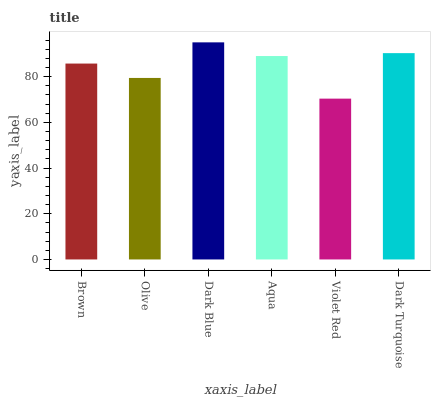Is Violet Red the minimum?
Answer yes or no. Yes. Is Dark Blue the maximum?
Answer yes or no. Yes. Is Olive the minimum?
Answer yes or no. No. Is Olive the maximum?
Answer yes or no. No. Is Brown greater than Olive?
Answer yes or no. Yes. Is Olive less than Brown?
Answer yes or no. Yes. Is Olive greater than Brown?
Answer yes or no. No. Is Brown less than Olive?
Answer yes or no. No. Is Aqua the high median?
Answer yes or no. Yes. Is Brown the low median?
Answer yes or no. Yes. Is Dark Turquoise the high median?
Answer yes or no. No. Is Violet Red the low median?
Answer yes or no. No. 